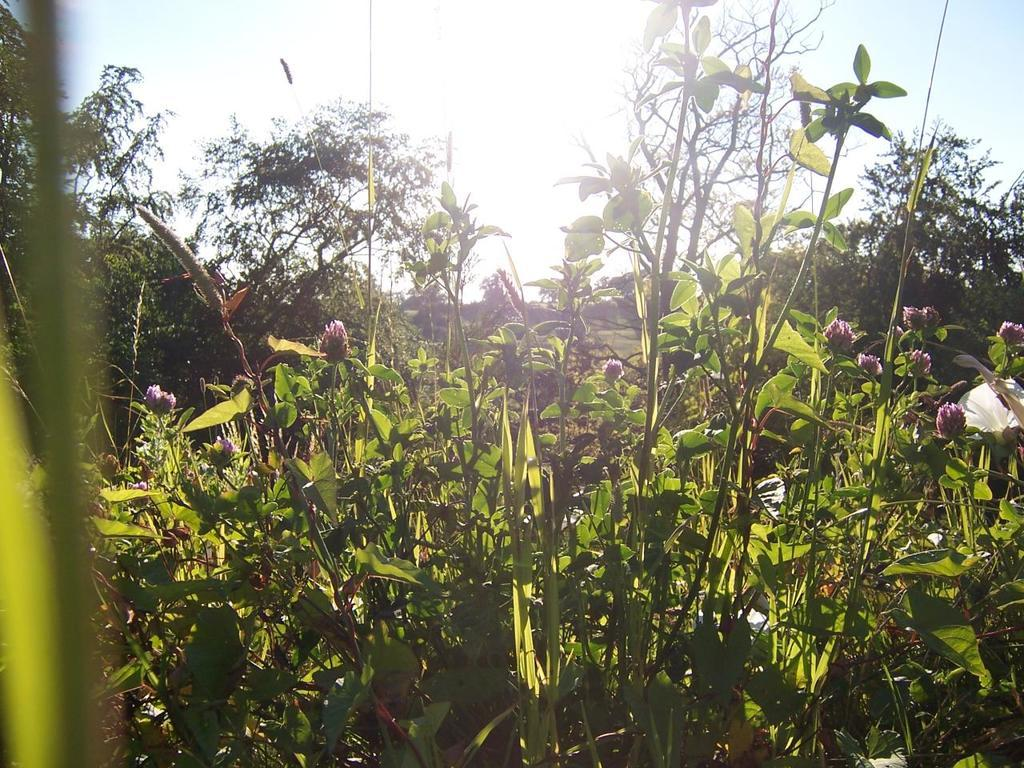What type of living organisms can be seen in the image? Plants can be seen in the image. Do the plants have any specific features? Yes, the plants have flowers. What is visible at the top of the image? The sky is visible at the top of the image. Can you tell me how many twigs are holding up the flowers in the image? There is no mention of twigs in the image; the plants have flowers, but no twigs are visible. What type of print can be seen on the flowers in the image? There is no print on the flowers in the image; they are simply flowers on the plants. 